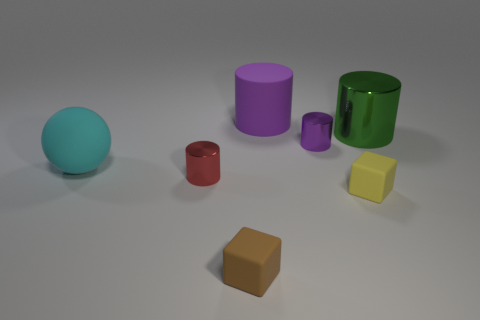Subtract all big rubber cylinders. How many cylinders are left? 3 Subtract all purple blocks. How many purple cylinders are left? 2 Add 1 cyan objects. How many objects exist? 8 Subtract all purple cylinders. How many cylinders are left? 2 Subtract all balls. How many objects are left? 6 Subtract all green cylinders. Subtract all red cubes. How many cylinders are left? 3 Add 6 large cyan rubber objects. How many large cyan rubber objects are left? 7 Add 7 red cylinders. How many red cylinders exist? 8 Subtract 0 green cubes. How many objects are left? 7 Subtract all large red matte objects. Subtract all tiny cylinders. How many objects are left? 5 